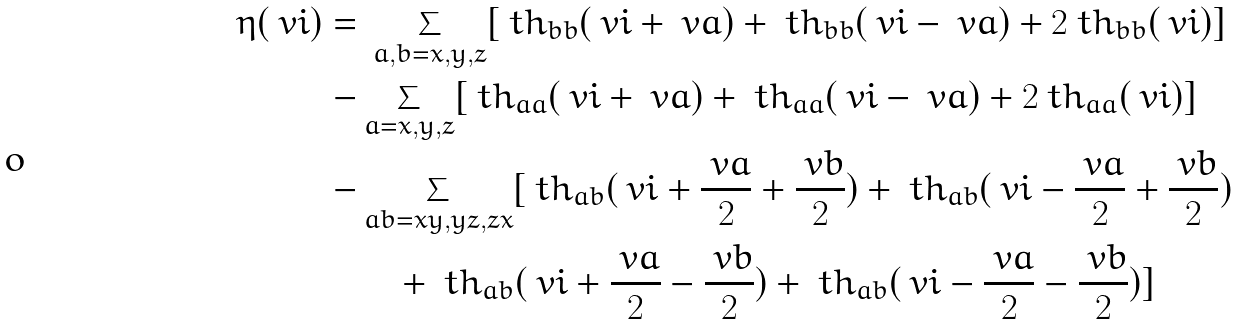Convert formula to latex. <formula><loc_0><loc_0><loc_500><loc_500>\eta ( \ v i ) = & \ \sum _ { a , b = x , y , z } [ \ t h _ { b b } ( \ v i + \ v a ) + \ t h _ { b b } ( \ v i - \ v a ) + 2 \ t h _ { b b } ( \ v i ) ] \\ - & \sum _ { a = x , y , z } [ \ t h _ { a a } ( \ v i + \ v a ) + \ t h _ { a a } ( \ v i - \ v a ) + 2 \ t h _ { a a } ( \ v i ) ] \\ - & \sum _ { a b = x y , y z , z x } [ \ t h _ { a b } ( \ v i + \frac { \ v a } { 2 } + \frac { \ v b } { 2 } ) + \ t h _ { a b } ( \ v i - \frac { \ v a } { 2 } + \frac { \ v b } { 2 } ) \\ & \quad + \ t h _ { a b } ( \ v i + \frac { \ v a } { 2 } - \frac { \ v b } { 2 } ) + \ t h _ { a b } ( \ v i - \frac { \ v a } { 2 } - \frac { \ v b } { 2 } ) ]</formula> 